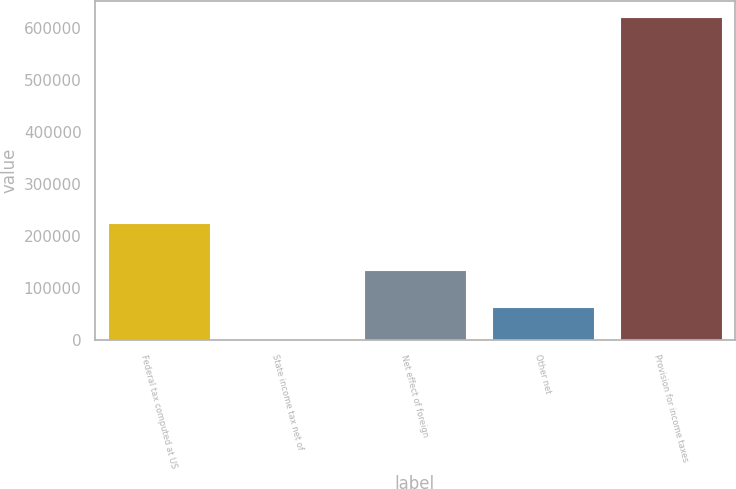<chart> <loc_0><loc_0><loc_500><loc_500><bar_chart><fcel>Federal tax computed at US<fcel>State income tax net of<fcel>Net effect of foreign<fcel>Other net<fcel>Provision for income taxes<nl><fcel>224384<fcel>1289<fcel>134117<fcel>63238.7<fcel>620786<nl></chart> 